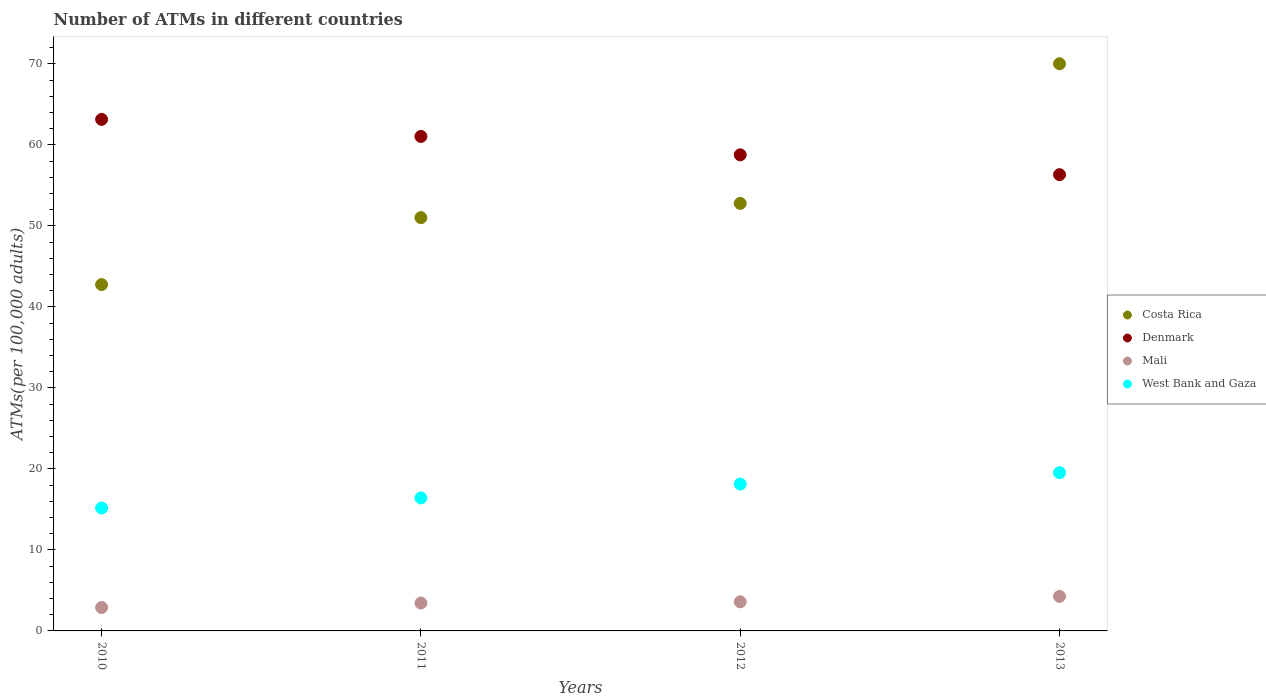Is the number of dotlines equal to the number of legend labels?
Give a very brief answer. Yes. What is the number of ATMs in West Bank and Gaza in 2012?
Give a very brief answer. 18.13. Across all years, what is the maximum number of ATMs in West Bank and Gaza?
Provide a succinct answer. 19.54. Across all years, what is the minimum number of ATMs in Mali?
Ensure brevity in your answer.  2.89. What is the total number of ATMs in Denmark in the graph?
Your response must be concise. 239.29. What is the difference between the number of ATMs in Mali in 2010 and that in 2013?
Offer a terse response. -1.37. What is the difference between the number of ATMs in Costa Rica in 2011 and the number of ATMs in West Bank and Gaza in 2013?
Provide a succinct answer. 31.48. What is the average number of ATMs in Denmark per year?
Make the answer very short. 59.82. In the year 2013, what is the difference between the number of ATMs in Mali and number of ATMs in Costa Rica?
Keep it short and to the point. -65.75. What is the ratio of the number of ATMs in West Bank and Gaza in 2011 to that in 2012?
Offer a very short reply. 0.91. Is the number of ATMs in West Bank and Gaza in 2010 less than that in 2011?
Provide a succinct answer. Yes. Is the difference between the number of ATMs in Mali in 2010 and 2012 greater than the difference between the number of ATMs in Costa Rica in 2010 and 2012?
Your answer should be compact. Yes. What is the difference between the highest and the second highest number of ATMs in Denmark?
Your answer should be very brief. 2.11. What is the difference between the highest and the lowest number of ATMs in Mali?
Keep it short and to the point. 1.37. In how many years, is the number of ATMs in Costa Rica greater than the average number of ATMs in Costa Rica taken over all years?
Keep it short and to the point. 1. Is it the case that in every year, the sum of the number of ATMs in West Bank and Gaza and number of ATMs in Denmark  is greater than the sum of number of ATMs in Costa Rica and number of ATMs in Mali?
Your response must be concise. No. How many dotlines are there?
Provide a short and direct response. 4. Are the values on the major ticks of Y-axis written in scientific E-notation?
Provide a succinct answer. No. Does the graph contain grids?
Offer a very short reply. No. Where does the legend appear in the graph?
Offer a terse response. Center right. How many legend labels are there?
Keep it short and to the point. 4. How are the legend labels stacked?
Your answer should be very brief. Vertical. What is the title of the graph?
Keep it short and to the point. Number of ATMs in different countries. Does "Madagascar" appear as one of the legend labels in the graph?
Provide a succinct answer. No. What is the label or title of the Y-axis?
Ensure brevity in your answer.  ATMs(per 100,0 adults). What is the ATMs(per 100,000 adults) of Costa Rica in 2010?
Your response must be concise. 42.75. What is the ATMs(per 100,000 adults) in Denmark in 2010?
Provide a short and direct response. 63.15. What is the ATMs(per 100,000 adults) in Mali in 2010?
Provide a short and direct response. 2.89. What is the ATMs(per 100,000 adults) of West Bank and Gaza in 2010?
Your answer should be very brief. 15.17. What is the ATMs(per 100,000 adults) in Costa Rica in 2011?
Your response must be concise. 51.02. What is the ATMs(per 100,000 adults) of Denmark in 2011?
Your answer should be compact. 61.04. What is the ATMs(per 100,000 adults) in Mali in 2011?
Your answer should be very brief. 3.44. What is the ATMs(per 100,000 adults) of West Bank and Gaza in 2011?
Provide a short and direct response. 16.42. What is the ATMs(per 100,000 adults) of Costa Rica in 2012?
Offer a terse response. 52.78. What is the ATMs(per 100,000 adults) in Denmark in 2012?
Ensure brevity in your answer.  58.77. What is the ATMs(per 100,000 adults) of Mali in 2012?
Make the answer very short. 3.59. What is the ATMs(per 100,000 adults) of West Bank and Gaza in 2012?
Provide a succinct answer. 18.13. What is the ATMs(per 100,000 adults) of Costa Rica in 2013?
Make the answer very short. 70.01. What is the ATMs(per 100,000 adults) of Denmark in 2013?
Offer a very short reply. 56.32. What is the ATMs(per 100,000 adults) in Mali in 2013?
Make the answer very short. 4.26. What is the ATMs(per 100,000 adults) in West Bank and Gaza in 2013?
Your answer should be compact. 19.54. Across all years, what is the maximum ATMs(per 100,000 adults) in Costa Rica?
Make the answer very short. 70.01. Across all years, what is the maximum ATMs(per 100,000 adults) of Denmark?
Your response must be concise. 63.15. Across all years, what is the maximum ATMs(per 100,000 adults) of Mali?
Make the answer very short. 4.26. Across all years, what is the maximum ATMs(per 100,000 adults) in West Bank and Gaza?
Keep it short and to the point. 19.54. Across all years, what is the minimum ATMs(per 100,000 adults) in Costa Rica?
Your answer should be very brief. 42.75. Across all years, what is the minimum ATMs(per 100,000 adults) in Denmark?
Provide a succinct answer. 56.32. Across all years, what is the minimum ATMs(per 100,000 adults) in Mali?
Give a very brief answer. 2.89. Across all years, what is the minimum ATMs(per 100,000 adults) of West Bank and Gaza?
Provide a short and direct response. 15.17. What is the total ATMs(per 100,000 adults) of Costa Rica in the graph?
Make the answer very short. 216.56. What is the total ATMs(per 100,000 adults) of Denmark in the graph?
Provide a succinct answer. 239.29. What is the total ATMs(per 100,000 adults) in Mali in the graph?
Offer a terse response. 14.18. What is the total ATMs(per 100,000 adults) of West Bank and Gaza in the graph?
Provide a succinct answer. 69.26. What is the difference between the ATMs(per 100,000 adults) of Costa Rica in 2010 and that in 2011?
Provide a short and direct response. -8.26. What is the difference between the ATMs(per 100,000 adults) in Denmark in 2010 and that in 2011?
Provide a succinct answer. 2.11. What is the difference between the ATMs(per 100,000 adults) of Mali in 2010 and that in 2011?
Your response must be concise. -0.55. What is the difference between the ATMs(per 100,000 adults) of West Bank and Gaza in 2010 and that in 2011?
Make the answer very short. -1.24. What is the difference between the ATMs(per 100,000 adults) in Costa Rica in 2010 and that in 2012?
Make the answer very short. -10.03. What is the difference between the ATMs(per 100,000 adults) in Denmark in 2010 and that in 2012?
Give a very brief answer. 4.38. What is the difference between the ATMs(per 100,000 adults) in Mali in 2010 and that in 2012?
Your answer should be compact. -0.7. What is the difference between the ATMs(per 100,000 adults) in West Bank and Gaza in 2010 and that in 2012?
Make the answer very short. -2.95. What is the difference between the ATMs(per 100,000 adults) in Costa Rica in 2010 and that in 2013?
Your answer should be compact. -27.26. What is the difference between the ATMs(per 100,000 adults) in Denmark in 2010 and that in 2013?
Keep it short and to the point. 6.83. What is the difference between the ATMs(per 100,000 adults) of Mali in 2010 and that in 2013?
Your response must be concise. -1.37. What is the difference between the ATMs(per 100,000 adults) in West Bank and Gaza in 2010 and that in 2013?
Your response must be concise. -4.37. What is the difference between the ATMs(per 100,000 adults) in Costa Rica in 2011 and that in 2012?
Provide a succinct answer. -1.76. What is the difference between the ATMs(per 100,000 adults) in Denmark in 2011 and that in 2012?
Make the answer very short. 2.27. What is the difference between the ATMs(per 100,000 adults) of Mali in 2011 and that in 2012?
Your response must be concise. -0.15. What is the difference between the ATMs(per 100,000 adults) in West Bank and Gaza in 2011 and that in 2012?
Make the answer very short. -1.71. What is the difference between the ATMs(per 100,000 adults) of Costa Rica in 2011 and that in 2013?
Your answer should be very brief. -19. What is the difference between the ATMs(per 100,000 adults) of Denmark in 2011 and that in 2013?
Your answer should be very brief. 4.72. What is the difference between the ATMs(per 100,000 adults) of Mali in 2011 and that in 2013?
Your answer should be very brief. -0.82. What is the difference between the ATMs(per 100,000 adults) in West Bank and Gaza in 2011 and that in 2013?
Offer a very short reply. -3.12. What is the difference between the ATMs(per 100,000 adults) in Costa Rica in 2012 and that in 2013?
Your answer should be very brief. -17.23. What is the difference between the ATMs(per 100,000 adults) of Denmark in 2012 and that in 2013?
Provide a short and direct response. 2.45. What is the difference between the ATMs(per 100,000 adults) of Mali in 2012 and that in 2013?
Keep it short and to the point. -0.67. What is the difference between the ATMs(per 100,000 adults) of West Bank and Gaza in 2012 and that in 2013?
Give a very brief answer. -1.41. What is the difference between the ATMs(per 100,000 adults) in Costa Rica in 2010 and the ATMs(per 100,000 adults) in Denmark in 2011?
Ensure brevity in your answer.  -18.29. What is the difference between the ATMs(per 100,000 adults) of Costa Rica in 2010 and the ATMs(per 100,000 adults) of Mali in 2011?
Your response must be concise. 39.31. What is the difference between the ATMs(per 100,000 adults) in Costa Rica in 2010 and the ATMs(per 100,000 adults) in West Bank and Gaza in 2011?
Make the answer very short. 26.34. What is the difference between the ATMs(per 100,000 adults) in Denmark in 2010 and the ATMs(per 100,000 adults) in Mali in 2011?
Offer a terse response. 59.71. What is the difference between the ATMs(per 100,000 adults) in Denmark in 2010 and the ATMs(per 100,000 adults) in West Bank and Gaza in 2011?
Make the answer very short. 46.73. What is the difference between the ATMs(per 100,000 adults) of Mali in 2010 and the ATMs(per 100,000 adults) of West Bank and Gaza in 2011?
Offer a very short reply. -13.53. What is the difference between the ATMs(per 100,000 adults) of Costa Rica in 2010 and the ATMs(per 100,000 adults) of Denmark in 2012?
Provide a succinct answer. -16.02. What is the difference between the ATMs(per 100,000 adults) in Costa Rica in 2010 and the ATMs(per 100,000 adults) in Mali in 2012?
Your answer should be compact. 39.16. What is the difference between the ATMs(per 100,000 adults) in Costa Rica in 2010 and the ATMs(per 100,000 adults) in West Bank and Gaza in 2012?
Ensure brevity in your answer.  24.63. What is the difference between the ATMs(per 100,000 adults) of Denmark in 2010 and the ATMs(per 100,000 adults) of Mali in 2012?
Your answer should be compact. 59.56. What is the difference between the ATMs(per 100,000 adults) of Denmark in 2010 and the ATMs(per 100,000 adults) of West Bank and Gaza in 2012?
Provide a short and direct response. 45.02. What is the difference between the ATMs(per 100,000 adults) of Mali in 2010 and the ATMs(per 100,000 adults) of West Bank and Gaza in 2012?
Your response must be concise. -15.24. What is the difference between the ATMs(per 100,000 adults) in Costa Rica in 2010 and the ATMs(per 100,000 adults) in Denmark in 2013?
Provide a short and direct response. -13.57. What is the difference between the ATMs(per 100,000 adults) of Costa Rica in 2010 and the ATMs(per 100,000 adults) of Mali in 2013?
Provide a succinct answer. 38.49. What is the difference between the ATMs(per 100,000 adults) of Costa Rica in 2010 and the ATMs(per 100,000 adults) of West Bank and Gaza in 2013?
Give a very brief answer. 23.21. What is the difference between the ATMs(per 100,000 adults) in Denmark in 2010 and the ATMs(per 100,000 adults) in Mali in 2013?
Your response must be concise. 58.89. What is the difference between the ATMs(per 100,000 adults) of Denmark in 2010 and the ATMs(per 100,000 adults) of West Bank and Gaza in 2013?
Offer a very short reply. 43.61. What is the difference between the ATMs(per 100,000 adults) of Mali in 2010 and the ATMs(per 100,000 adults) of West Bank and Gaza in 2013?
Give a very brief answer. -16.65. What is the difference between the ATMs(per 100,000 adults) of Costa Rica in 2011 and the ATMs(per 100,000 adults) of Denmark in 2012?
Provide a succinct answer. -7.75. What is the difference between the ATMs(per 100,000 adults) of Costa Rica in 2011 and the ATMs(per 100,000 adults) of Mali in 2012?
Provide a succinct answer. 47.43. What is the difference between the ATMs(per 100,000 adults) in Costa Rica in 2011 and the ATMs(per 100,000 adults) in West Bank and Gaza in 2012?
Your answer should be compact. 32.89. What is the difference between the ATMs(per 100,000 adults) in Denmark in 2011 and the ATMs(per 100,000 adults) in Mali in 2012?
Your answer should be compact. 57.45. What is the difference between the ATMs(per 100,000 adults) of Denmark in 2011 and the ATMs(per 100,000 adults) of West Bank and Gaza in 2012?
Your response must be concise. 42.91. What is the difference between the ATMs(per 100,000 adults) in Mali in 2011 and the ATMs(per 100,000 adults) in West Bank and Gaza in 2012?
Provide a short and direct response. -14.69. What is the difference between the ATMs(per 100,000 adults) in Costa Rica in 2011 and the ATMs(per 100,000 adults) in Denmark in 2013?
Your answer should be compact. -5.31. What is the difference between the ATMs(per 100,000 adults) in Costa Rica in 2011 and the ATMs(per 100,000 adults) in Mali in 2013?
Provide a short and direct response. 46.76. What is the difference between the ATMs(per 100,000 adults) of Costa Rica in 2011 and the ATMs(per 100,000 adults) of West Bank and Gaza in 2013?
Provide a short and direct response. 31.48. What is the difference between the ATMs(per 100,000 adults) of Denmark in 2011 and the ATMs(per 100,000 adults) of Mali in 2013?
Provide a succinct answer. 56.78. What is the difference between the ATMs(per 100,000 adults) in Denmark in 2011 and the ATMs(per 100,000 adults) in West Bank and Gaza in 2013?
Provide a short and direct response. 41.5. What is the difference between the ATMs(per 100,000 adults) of Mali in 2011 and the ATMs(per 100,000 adults) of West Bank and Gaza in 2013?
Keep it short and to the point. -16.1. What is the difference between the ATMs(per 100,000 adults) of Costa Rica in 2012 and the ATMs(per 100,000 adults) of Denmark in 2013?
Your response must be concise. -3.54. What is the difference between the ATMs(per 100,000 adults) in Costa Rica in 2012 and the ATMs(per 100,000 adults) in Mali in 2013?
Offer a terse response. 48.52. What is the difference between the ATMs(per 100,000 adults) in Costa Rica in 2012 and the ATMs(per 100,000 adults) in West Bank and Gaza in 2013?
Provide a short and direct response. 33.24. What is the difference between the ATMs(per 100,000 adults) of Denmark in 2012 and the ATMs(per 100,000 adults) of Mali in 2013?
Ensure brevity in your answer.  54.51. What is the difference between the ATMs(per 100,000 adults) in Denmark in 2012 and the ATMs(per 100,000 adults) in West Bank and Gaza in 2013?
Your answer should be very brief. 39.23. What is the difference between the ATMs(per 100,000 adults) of Mali in 2012 and the ATMs(per 100,000 adults) of West Bank and Gaza in 2013?
Offer a terse response. -15.95. What is the average ATMs(per 100,000 adults) in Costa Rica per year?
Offer a terse response. 54.14. What is the average ATMs(per 100,000 adults) in Denmark per year?
Your answer should be very brief. 59.82. What is the average ATMs(per 100,000 adults) in Mali per year?
Ensure brevity in your answer.  3.55. What is the average ATMs(per 100,000 adults) of West Bank and Gaza per year?
Your answer should be very brief. 17.31. In the year 2010, what is the difference between the ATMs(per 100,000 adults) in Costa Rica and ATMs(per 100,000 adults) in Denmark?
Provide a succinct answer. -20.4. In the year 2010, what is the difference between the ATMs(per 100,000 adults) of Costa Rica and ATMs(per 100,000 adults) of Mali?
Give a very brief answer. 39.86. In the year 2010, what is the difference between the ATMs(per 100,000 adults) in Costa Rica and ATMs(per 100,000 adults) in West Bank and Gaza?
Offer a very short reply. 27.58. In the year 2010, what is the difference between the ATMs(per 100,000 adults) in Denmark and ATMs(per 100,000 adults) in Mali?
Your response must be concise. 60.26. In the year 2010, what is the difference between the ATMs(per 100,000 adults) of Denmark and ATMs(per 100,000 adults) of West Bank and Gaza?
Ensure brevity in your answer.  47.97. In the year 2010, what is the difference between the ATMs(per 100,000 adults) of Mali and ATMs(per 100,000 adults) of West Bank and Gaza?
Your answer should be compact. -12.28. In the year 2011, what is the difference between the ATMs(per 100,000 adults) of Costa Rica and ATMs(per 100,000 adults) of Denmark?
Keep it short and to the point. -10.02. In the year 2011, what is the difference between the ATMs(per 100,000 adults) in Costa Rica and ATMs(per 100,000 adults) in Mali?
Your answer should be very brief. 47.58. In the year 2011, what is the difference between the ATMs(per 100,000 adults) of Costa Rica and ATMs(per 100,000 adults) of West Bank and Gaza?
Your response must be concise. 34.6. In the year 2011, what is the difference between the ATMs(per 100,000 adults) of Denmark and ATMs(per 100,000 adults) of Mali?
Keep it short and to the point. 57.6. In the year 2011, what is the difference between the ATMs(per 100,000 adults) in Denmark and ATMs(per 100,000 adults) in West Bank and Gaza?
Provide a short and direct response. 44.63. In the year 2011, what is the difference between the ATMs(per 100,000 adults) in Mali and ATMs(per 100,000 adults) in West Bank and Gaza?
Your answer should be compact. -12.98. In the year 2012, what is the difference between the ATMs(per 100,000 adults) of Costa Rica and ATMs(per 100,000 adults) of Denmark?
Offer a very short reply. -5.99. In the year 2012, what is the difference between the ATMs(per 100,000 adults) in Costa Rica and ATMs(per 100,000 adults) in Mali?
Offer a very short reply. 49.19. In the year 2012, what is the difference between the ATMs(per 100,000 adults) in Costa Rica and ATMs(per 100,000 adults) in West Bank and Gaza?
Your answer should be very brief. 34.65. In the year 2012, what is the difference between the ATMs(per 100,000 adults) of Denmark and ATMs(per 100,000 adults) of Mali?
Make the answer very short. 55.18. In the year 2012, what is the difference between the ATMs(per 100,000 adults) in Denmark and ATMs(per 100,000 adults) in West Bank and Gaza?
Your response must be concise. 40.65. In the year 2012, what is the difference between the ATMs(per 100,000 adults) of Mali and ATMs(per 100,000 adults) of West Bank and Gaza?
Keep it short and to the point. -14.54. In the year 2013, what is the difference between the ATMs(per 100,000 adults) in Costa Rica and ATMs(per 100,000 adults) in Denmark?
Your answer should be very brief. 13.69. In the year 2013, what is the difference between the ATMs(per 100,000 adults) in Costa Rica and ATMs(per 100,000 adults) in Mali?
Offer a very short reply. 65.75. In the year 2013, what is the difference between the ATMs(per 100,000 adults) in Costa Rica and ATMs(per 100,000 adults) in West Bank and Gaza?
Ensure brevity in your answer.  50.47. In the year 2013, what is the difference between the ATMs(per 100,000 adults) of Denmark and ATMs(per 100,000 adults) of Mali?
Provide a short and direct response. 52.06. In the year 2013, what is the difference between the ATMs(per 100,000 adults) of Denmark and ATMs(per 100,000 adults) of West Bank and Gaza?
Your response must be concise. 36.78. In the year 2013, what is the difference between the ATMs(per 100,000 adults) of Mali and ATMs(per 100,000 adults) of West Bank and Gaza?
Provide a succinct answer. -15.28. What is the ratio of the ATMs(per 100,000 adults) in Costa Rica in 2010 to that in 2011?
Offer a terse response. 0.84. What is the ratio of the ATMs(per 100,000 adults) of Denmark in 2010 to that in 2011?
Give a very brief answer. 1.03. What is the ratio of the ATMs(per 100,000 adults) of Mali in 2010 to that in 2011?
Ensure brevity in your answer.  0.84. What is the ratio of the ATMs(per 100,000 adults) in West Bank and Gaza in 2010 to that in 2011?
Offer a very short reply. 0.92. What is the ratio of the ATMs(per 100,000 adults) of Costa Rica in 2010 to that in 2012?
Your response must be concise. 0.81. What is the ratio of the ATMs(per 100,000 adults) in Denmark in 2010 to that in 2012?
Offer a terse response. 1.07. What is the ratio of the ATMs(per 100,000 adults) of Mali in 2010 to that in 2012?
Offer a terse response. 0.8. What is the ratio of the ATMs(per 100,000 adults) of West Bank and Gaza in 2010 to that in 2012?
Your response must be concise. 0.84. What is the ratio of the ATMs(per 100,000 adults) of Costa Rica in 2010 to that in 2013?
Ensure brevity in your answer.  0.61. What is the ratio of the ATMs(per 100,000 adults) in Denmark in 2010 to that in 2013?
Keep it short and to the point. 1.12. What is the ratio of the ATMs(per 100,000 adults) in Mali in 2010 to that in 2013?
Make the answer very short. 0.68. What is the ratio of the ATMs(per 100,000 adults) in West Bank and Gaza in 2010 to that in 2013?
Offer a terse response. 0.78. What is the ratio of the ATMs(per 100,000 adults) in Costa Rica in 2011 to that in 2012?
Your response must be concise. 0.97. What is the ratio of the ATMs(per 100,000 adults) in Denmark in 2011 to that in 2012?
Offer a very short reply. 1.04. What is the ratio of the ATMs(per 100,000 adults) of Mali in 2011 to that in 2012?
Your answer should be very brief. 0.96. What is the ratio of the ATMs(per 100,000 adults) in West Bank and Gaza in 2011 to that in 2012?
Your answer should be compact. 0.91. What is the ratio of the ATMs(per 100,000 adults) in Costa Rica in 2011 to that in 2013?
Ensure brevity in your answer.  0.73. What is the ratio of the ATMs(per 100,000 adults) in Denmark in 2011 to that in 2013?
Ensure brevity in your answer.  1.08. What is the ratio of the ATMs(per 100,000 adults) in Mali in 2011 to that in 2013?
Your answer should be compact. 0.81. What is the ratio of the ATMs(per 100,000 adults) in West Bank and Gaza in 2011 to that in 2013?
Provide a succinct answer. 0.84. What is the ratio of the ATMs(per 100,000 adults) in Costa Rica in 2012 to that in 2013?
Keep it short and to the point. 0.75. What is the ratio of the ATMs(per 100,000 adults) of Denmark in 2012 to that in 2013?
Your answer should be very brief. 1.04. What is the ratio of the ATMs(per 100,000 adults) of Mali in 2012 to that in 2013?
Give a very brief answer. 0.84. What is the ratio of the ATMs(per 100,000 adults) of West Bank and Gaza in 2012 to that in 2013?
Provide a succinct answer. 0.93. What is the difference between the highest and the second highest ATMs(per 100,000 adults) in Costa Rica?
Keep it short and to the point. 17.23. What is the difference between the highest and the second highest ATMs(per 100,000 adults) of Denmark?
Your answer should be very brief. 2.11. What is the difference between the highest and the second highest ATMs(per 100,000 adults) of Mali?
Your answer should be compact. 0.67. What is the difference between the highest and the second highest ATMs(per 100,000 adults) of West Bank and Gaza?
Your answer should be compact. 1.41. What is the difference between the highest and the lowest ATMs(per 100,000 adults) of Costa Rica?
Provide a succinct answer. 27.26. What is the difference between the highest and the lowest ATMs(per 100,000 adults) of Denmark?
Ensure brevity in your answer.  6.83. What is the difference between the highest and the lowest ATMs(per 100,000 adults) in Mali?
Provide a short and direct response. 1.37. What is the difference between the highest and the lowest ATMs(per 100,000 adults) of West Bank and Gaza?
Your response must be concise. 4.37. 